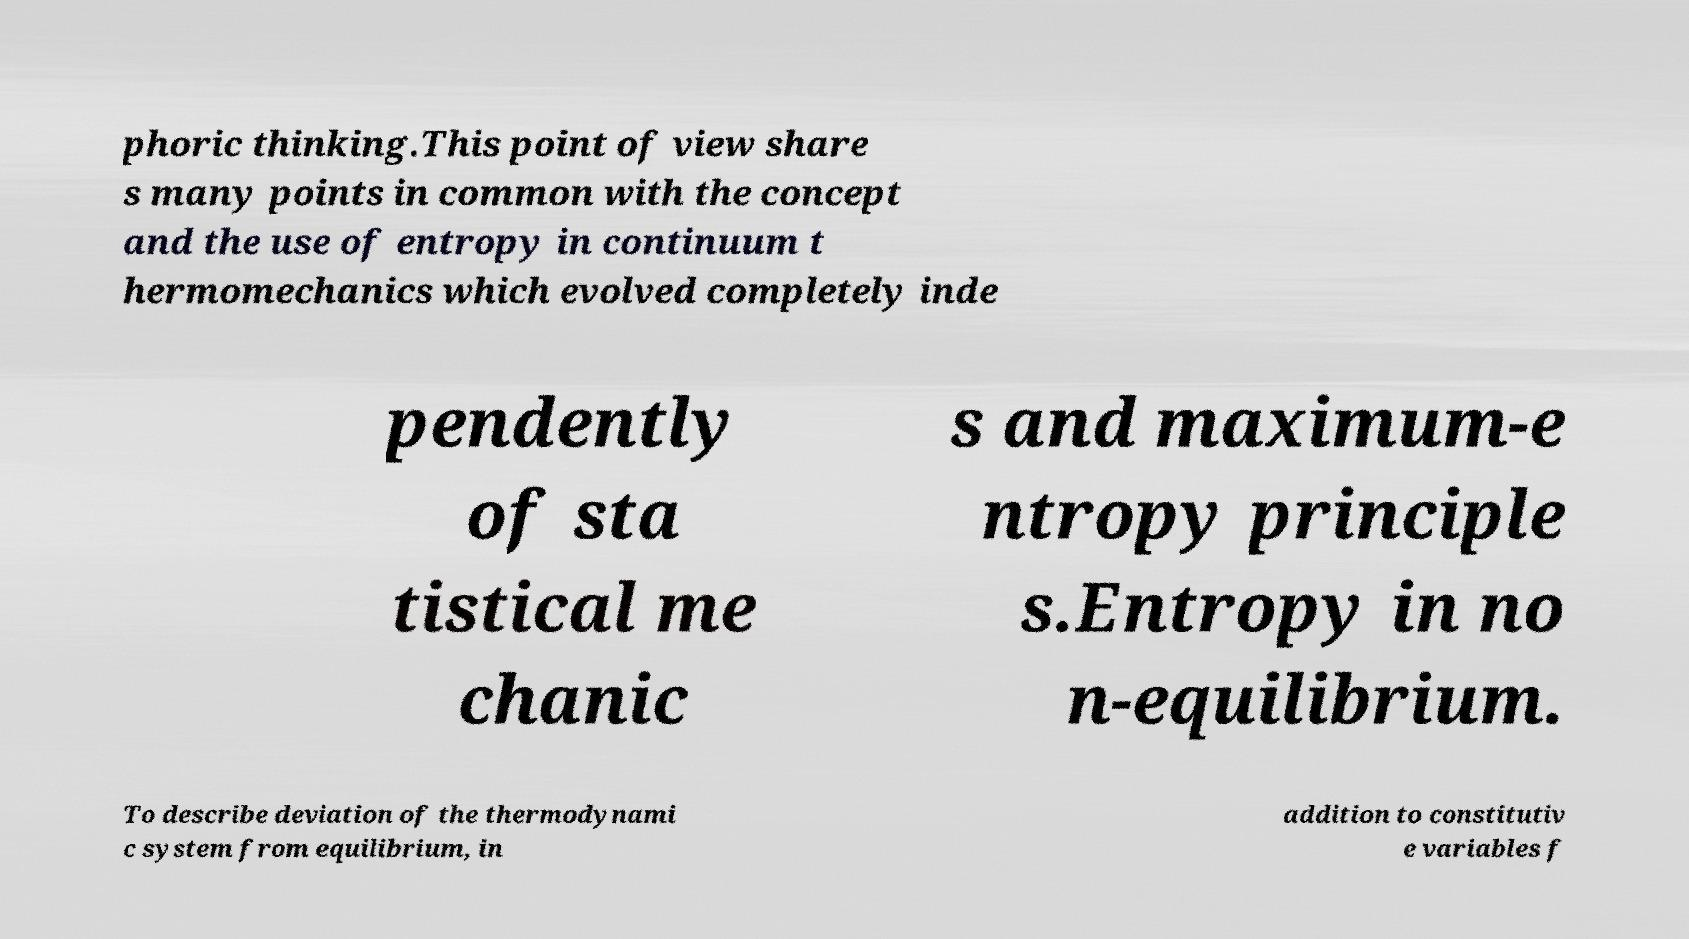Can you read and provide the text displayed in the image?This photo seems to have some interesting text. Can you extract and type it out for me? phoric thinking.This point of view share s many points in common with the concept and the use of entropy in continuum t hermomechanics which evolved completely inde pendently of sta tistical me chanic s and maximum-e ntropy principle s.Entropy in no n-equilibrium. To describe deviation of the thermodynami c system from equilibrium, in addition to constitutiv e variables f 